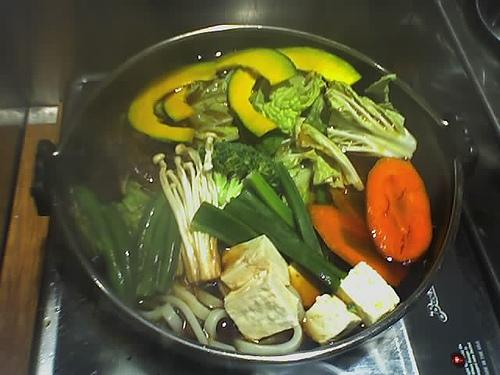What are the white blocks in the soup called? tofu 